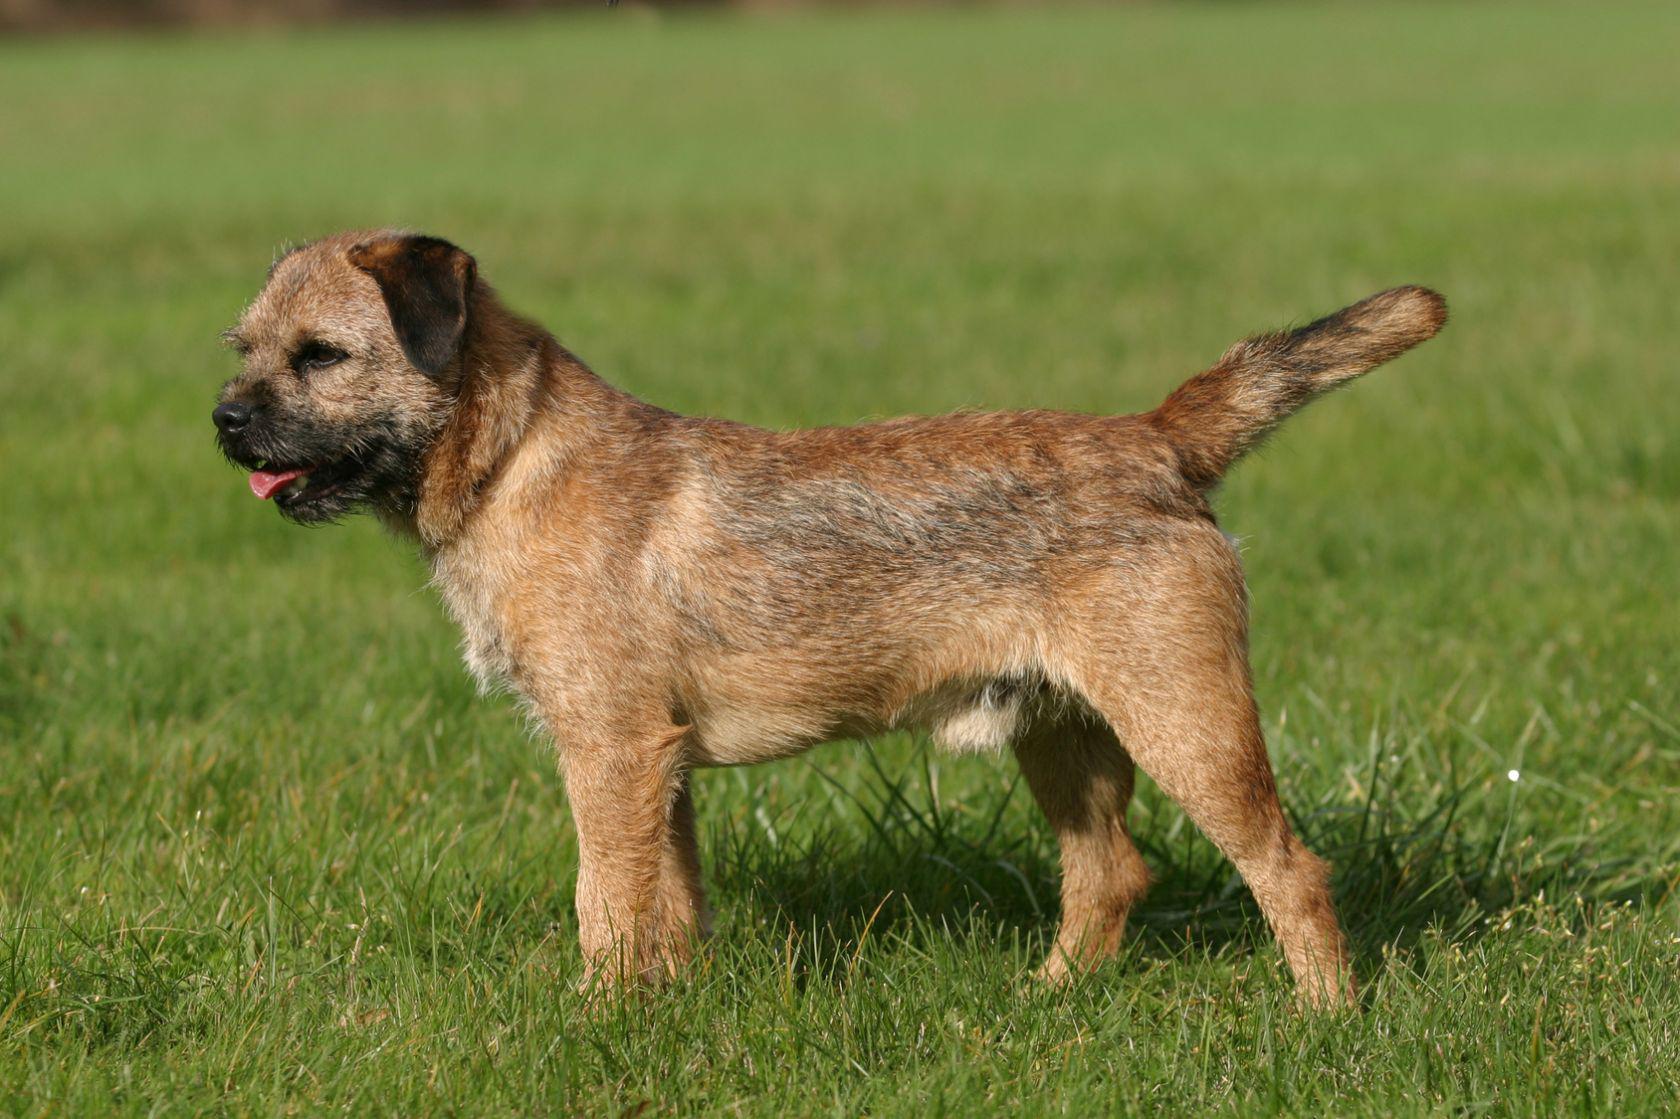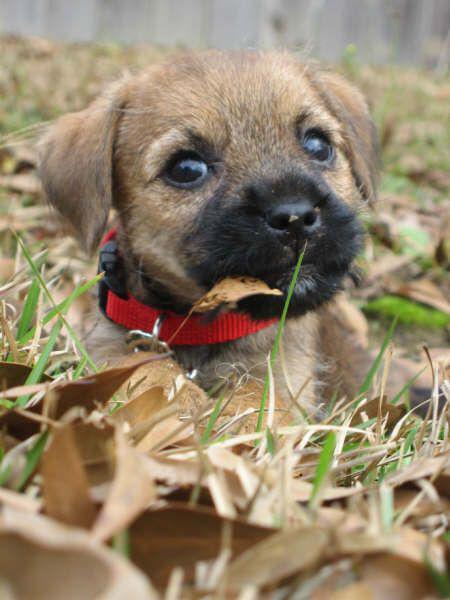The first image is the image on the left, the second image is the image on the right. Analyze the images presented: Is the assertion "The left image shows a dog standing with all four paws on the ground." valid? Answer yes or no. Yes. 